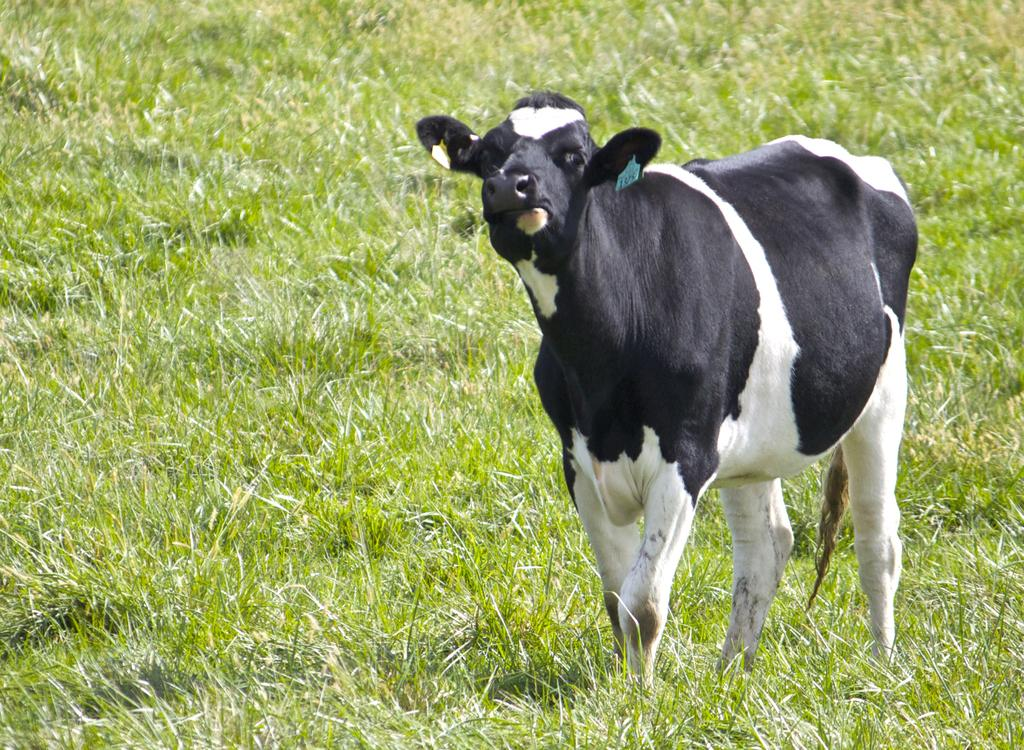What type of animal is in the image? There is a black and white cow in the image. What can be seen on the cow's ears? The cow has tags on its ears. What is on the ground in the image? There is grass on the ground in the image. How does the cow demonstrate fear in the image? The image does not show the cow demonstrating fear, as there is no indication of fear or any other emotion in the cow's expression or body language. 